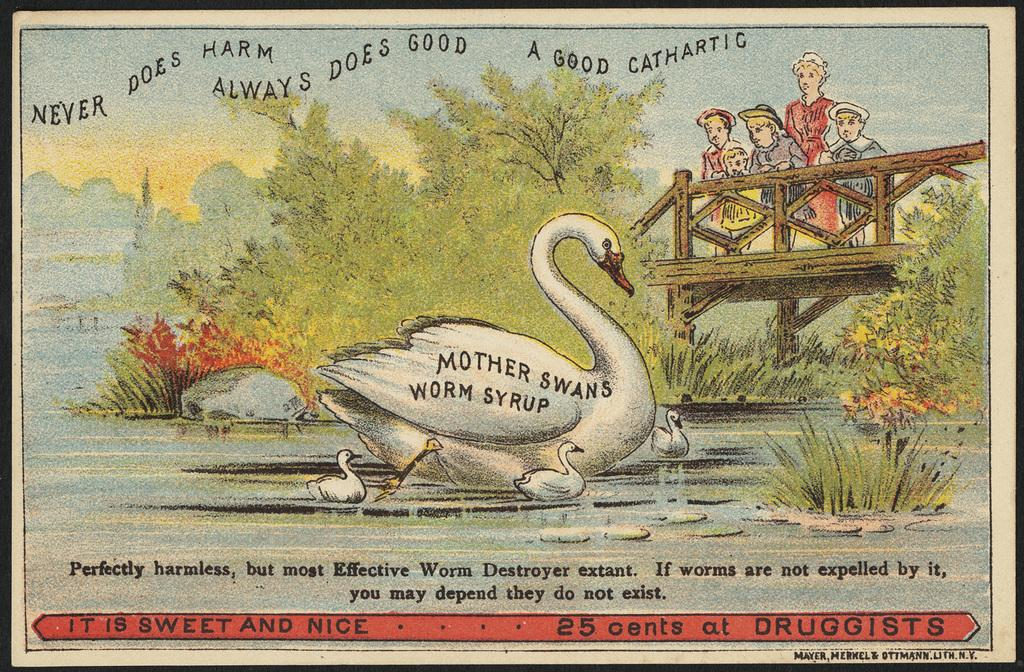What type of visual is the image? The image is a poster. What subjects are depicted on the poster? There are depictions of persons and a swan on the poster. Is there any text present on the poster? Yes, there is text on the poster. What brand of toothpaste is advertised on the poster? There is no toothpaste present on the poster, so it cannot be determined which brand might be advertised. 